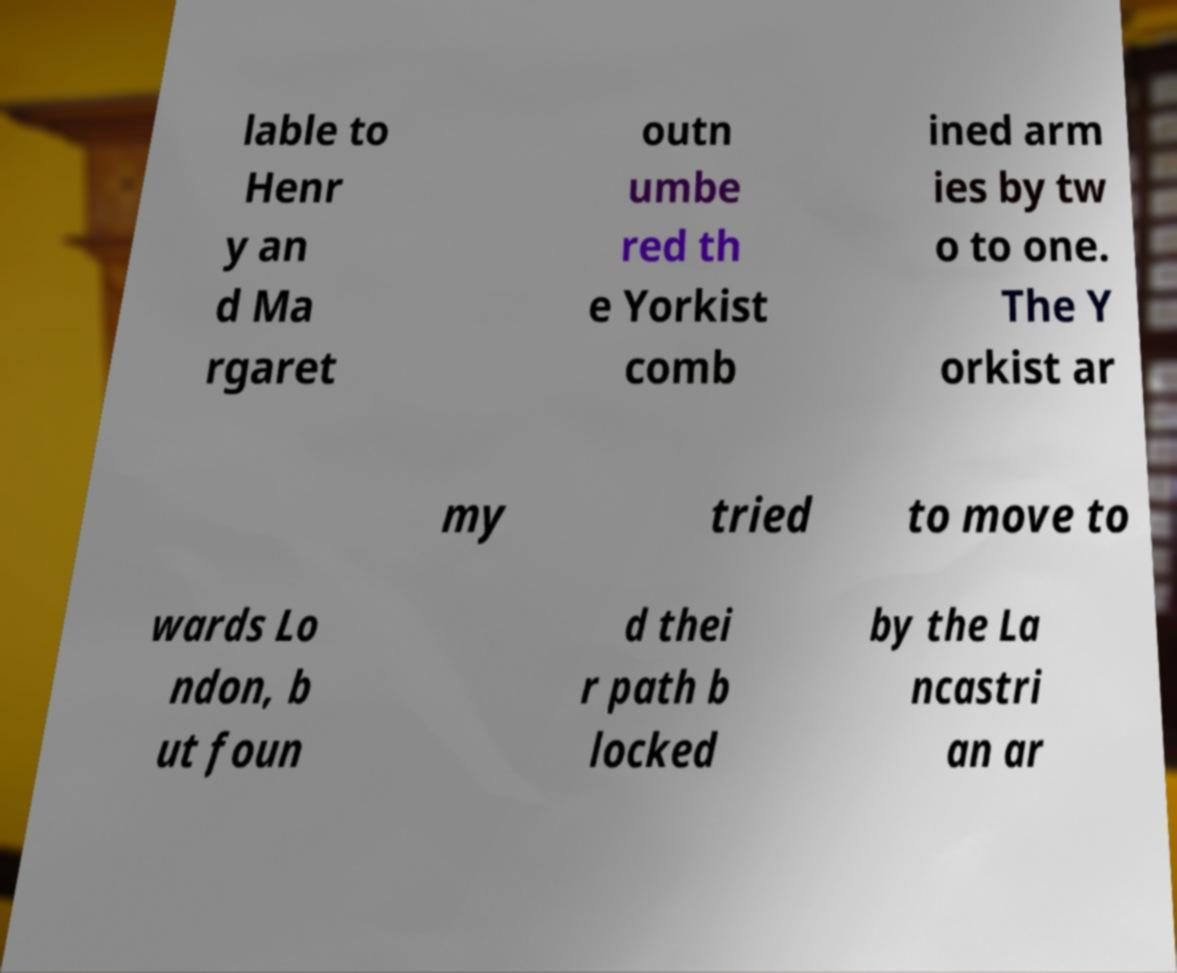What messages or text are displayed in this image? I need them in a readable, typed format. lable to Henr y an d Ma rgaret outn umbe red th e Yorkist comb ined arm ies by tw o to one. The Y orkist ar my tried to move to wards Lo ndon, b ut foun d thei r path b locked by the La ncastri an ar 